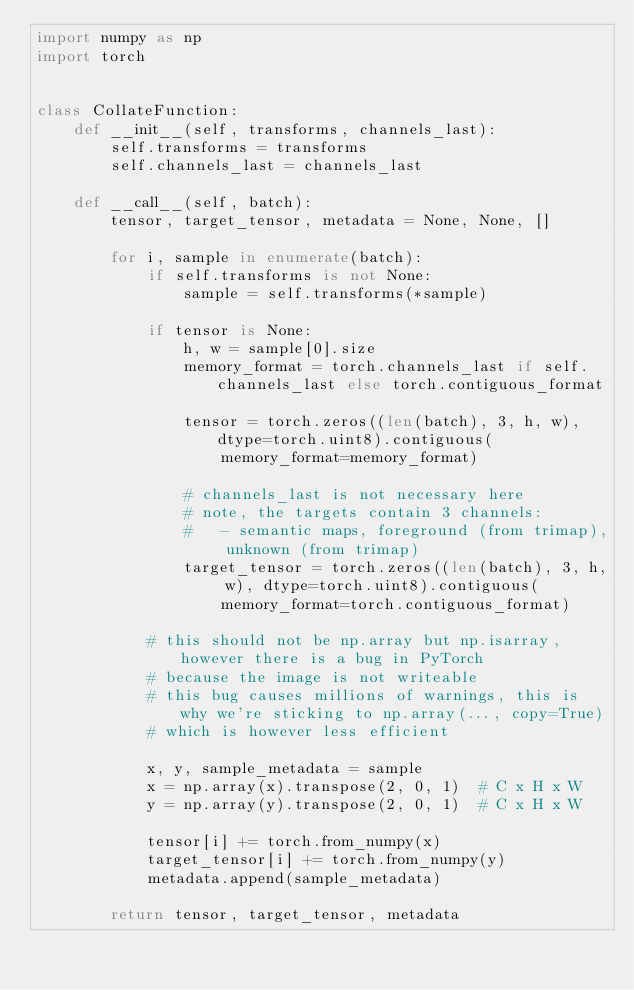Convert code to text. <code><loc_0><loc_0><loc_500><loc_500><_Python_>import numpy as np
import torch


class CollateFunction:
    def __init__(self, transforms, channels_last):
        self.transforms = transforms
        self.channels_last = channels_last

    def __call__(self, batch):
        tensor, target_tensor, metadata = None, None, []

        for i, sample in enumerate(batch):
            if self.transforms is not None:
                sample = self.transforms(*sample)

            if tensor is None:
                h, w = sample[0].size
                memory_format = torch.channels_last if self.channels_last else torch.contiguous_format

                tensor = torch.zeros((len(batch), 3, h, w), dtype=torch.uint8).contiguous(
                    memory_format=memory_format)

                # channels_last is not necessary here
                # note, the targets contain 3 channels:
                #   - semantic maps, foreground (from trimap), unknown (from trimap)
                target_tensor = torch.zeros((len(batch), 3, h, w), dtype=torch.uint8).contiguous(
                    memory_format=torch.contiguous_format)

            # this should not be np.array but np.isarray, however there is a bug in PyTorch
            # because the image is not writeable
            # this bug causes millions of warnings, this is why we're sticking to np.array(..., copy=True)
            # which is however less efficient

            x, y, sample_metadata = sample
            x = np.array(x).transpose(2, 0, 1)  # C x H x W
            y = np.array(y).transpose(2, 0, 1)  # C x H x W

            tensor[i] += torch.from_numpy(x)
            target_tensor[i] += torch.from_numpy(y)
            metadata.append(sample_metadata)

        return tensor, target_tensor, metadata
</code> 